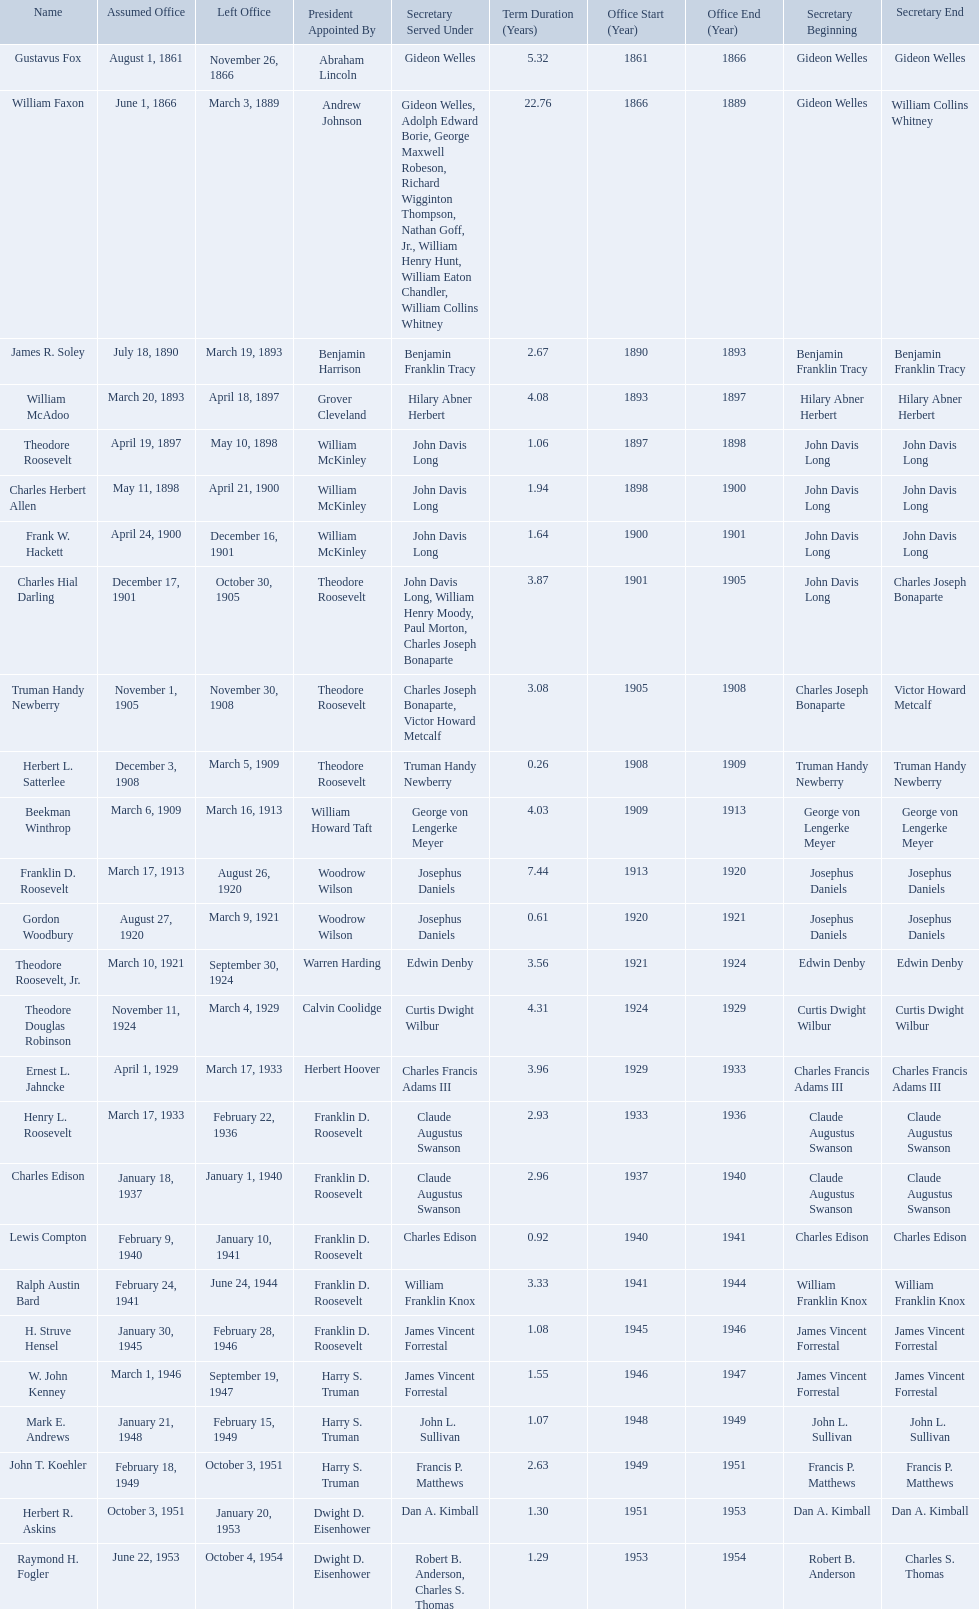Who were all the assistant secretary's of the navy? Gustavus Fox, William Faxon, James R. Soley, William McAdoo, Theodore Roosevelt, Charles Herbert Allen, Frank W. Hackett, Charles Hial Darling, Truman Handy Newberry, Herbert L. Satterlee, Beekman Winthrop, Franklin D. Roosevelt, Gordon Woodbury, Theodore Roosevelt, Jr., Theodore Douglas Robinson, Ernest L. Jahncke, Henry L. Roosevelt, Charles Edison, Lewis Compton, Ralph Austin Bard, H. Struve Hensel, W. John Kenney, Mark E. Andrews, John T. Koehler, Herbert R. Askins, Raymond H. Fogler. What are the various dates they left office in? November 26, 1866, March 3, 1889, March 19, 1893, April 18, 1897, May 10, 1898, April 21, 1900, December 16, 1901, October 30, 1905, November 30, 1908, March 5, 1909, March 16, 1913, August 26, 1920, March 9, 1921, September 30, 1924, March 4, 1929, March 17, 1933, February 22, 1936, January 1, 1940, January 10, 1941, June 24, 1944, February 28, 1946, September 19, 1947, February 15, 1949, October 3, 1951, January 20, 1953, October 4, 1954. Of these dates, which was the date raymond h. fogler left office in? October 4, 1954. Who are all of the assistant secretaries of the navy in the 20th century? Charles Herbert Allen, Frank W. Hackett, Charles Hial Darling, Truman Handy Newberry, Herbert L. Satterlee, Beekman Winthrop, Franklin D. Roosevelt, Gordon Woodbury, Theodore Roosevelt, Jr., Theodore Douglas Robinson, Ernest L. Jahncke, Henry L. Roosevelt, Charles Edison, Lewis Compton, Ralph Austin Bard, H. Struve Hensel, W. John Kenney, Mark E. Andrews, John T. Koehler, Herbert R. Askins, Raymond H. Fogler. What date was assistant secretary of the navy raymond h. fogler appointed? June 22, 1953. What date did assistant secretary of the navy raymond h. fogler leave office? October 4, 1954. 